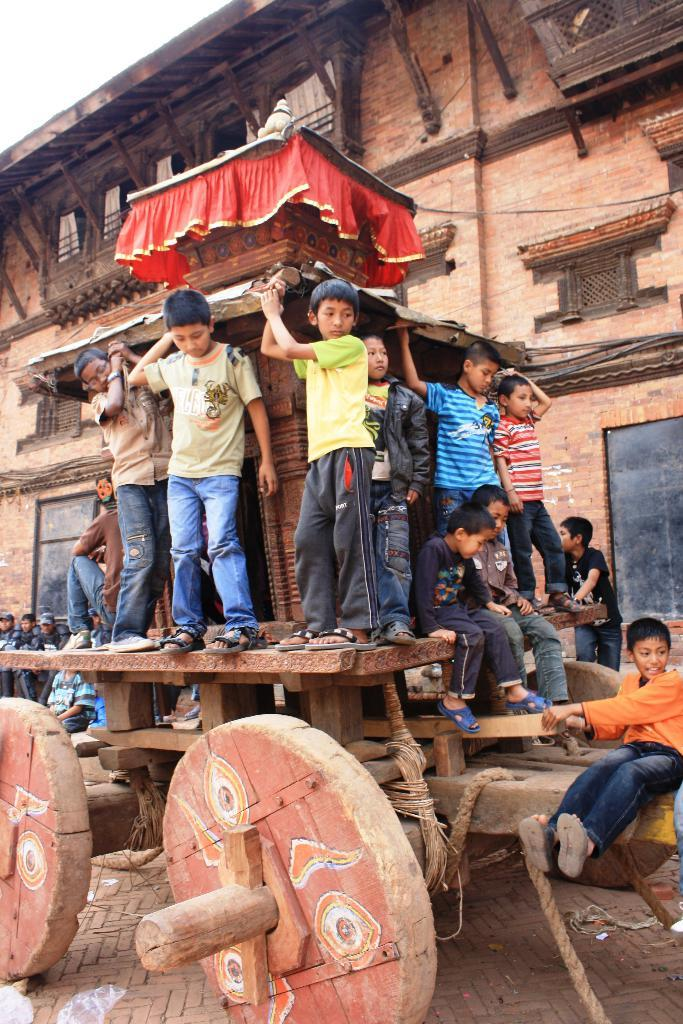How many people are in the image? There is a group of people in the image, but the exact number cannot be determined from the provided facts. What object can be seen in the image besides the people? There is a cart in the image. What can be seen in the background of the image? There is a building in the background of the image. What type of eggnog is being served from the cart in the image? There is no mention of eggnog or any type of beverage being served from the cart in the image. 